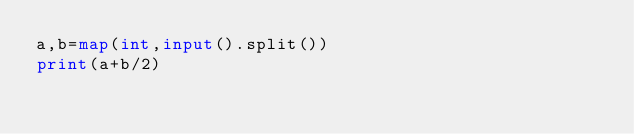Convert code to text. <code><loc_0><loc_0><loc_500><loc_500><_Python_>a,b=map(int,input().split())
print(a+b/2)</code> 